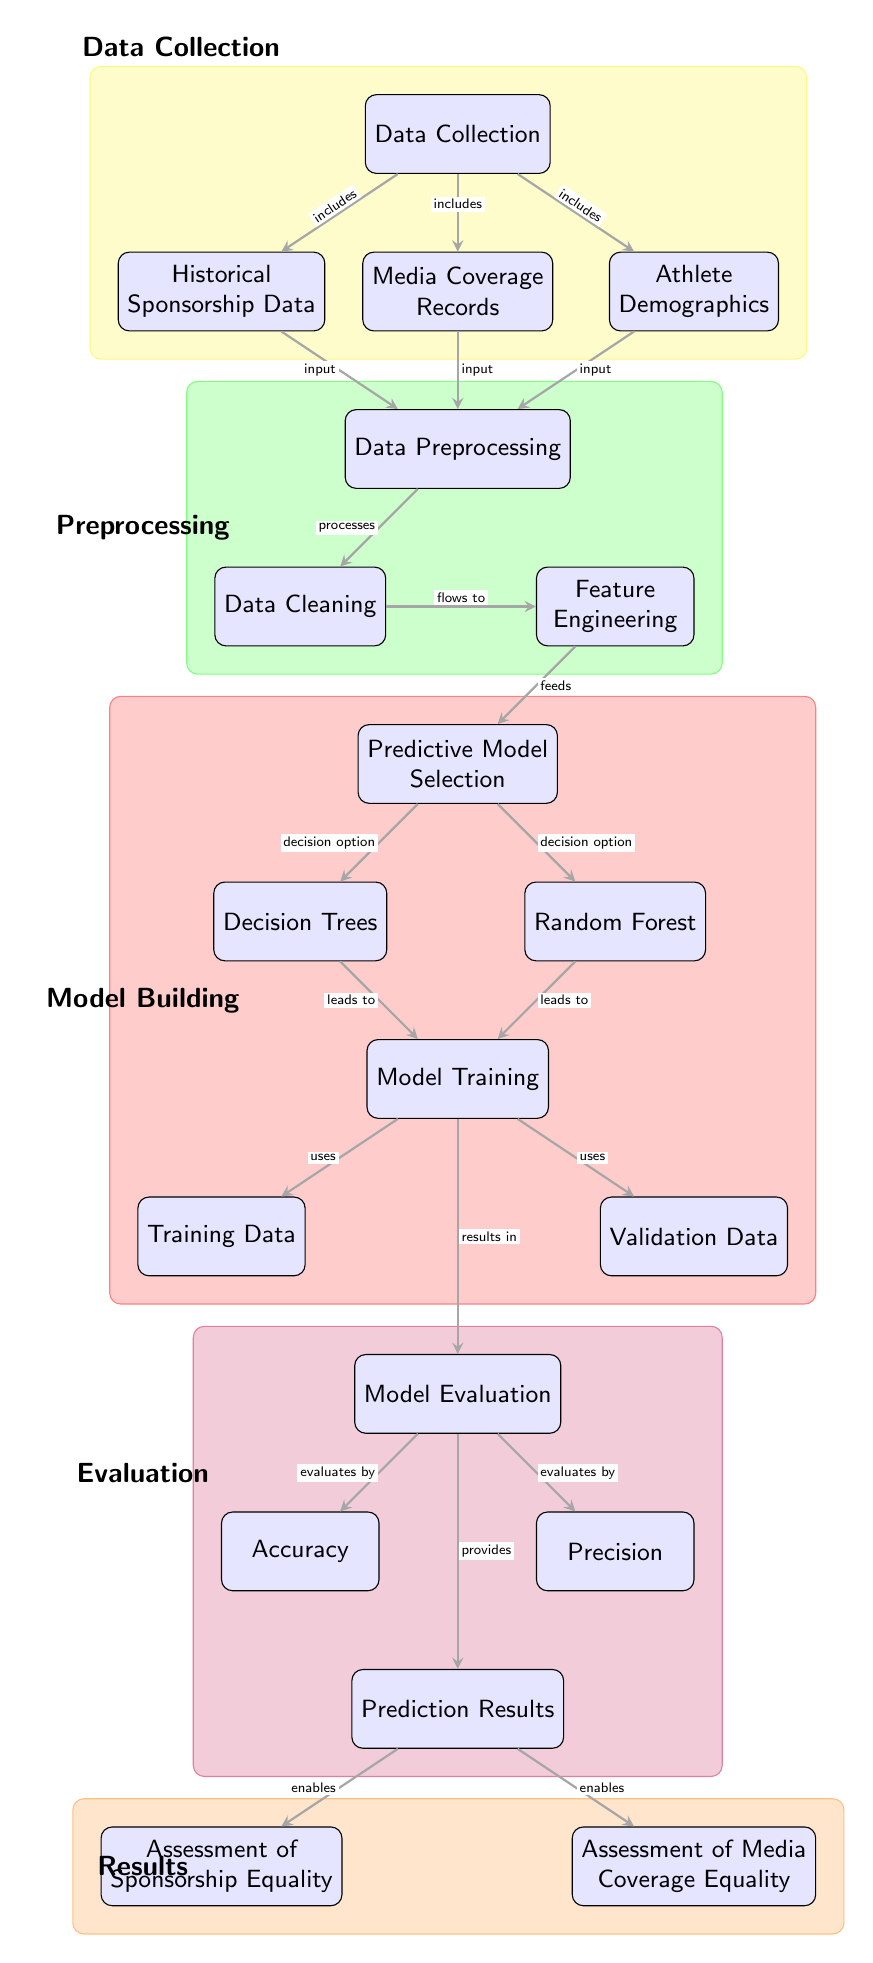What is the first step in the diagram? The first step in the diagram is "Data Collection," located at the top of the flow, indicating that the process begins with gathering relevant data.
Answer: Data Collection How many types of predictive models are mentioned in the diagram? The diagram mentions two types of predictive models: "Decision Trees" and "Random Forest," which can be found at the same level under "Predictive Model Selection."
Answer: Two What are the three main inputs for "Data Preprocessing"? The three main inputs listed for "Data Preprocessing" are "Historical Sponsorship Data," "Media Coverage Records," and "Athlete Demographics," which all connect to this node.
Answer: Historical Sponsorship Data, Media Coverage Records, Athlete Demographics What does "Model Evaluation" result in? "Model Evaluation" leads to three evaluations: "Accuracy," "Precision," and "Prediction Results," indicating the metrics and outcomes assessed after training the models.
Answer: Accuracy, Precision, Prediction Results How does "Prediction Results" affect the assessments of equality? "Prediction Results" enables both "Assessment of Sponsorship Equality" and "Assessment of Media Coverage Equality," showing that the outcomes from predictions inform these assessments.
Answer: Enables Which part of the diagram focuses on data preparation? The part of the diagram that focuses on data preparation is "Data Preprocessing," which includes "Data Cleaning" and "Feature Engineering," indicating its role in preparing the collected data for modeling.
Answer: Data Preprocessing What are the two types of data used in model training? The two types of data used in "Model Training" are "Training Data" and "Validation Data," showing that both datasets are crucial for training and validating the models.
Answer: Training Data, Validation Data Which phase in the diagram contains the node "Assessment of Media Coverage Equality"? The "Results" phase of the diagram contains the node "Assessment of Media Coverage Equality," which is located at the bottom section of the flow.
Answer: Results What kind of analysis does the diagram primarily focus on? The diagram primarily focuses on "Predictive Analytics for Sponsorship and Media Coverage Equality," indicating its objective to analyze sponsorship and media coverage related to athletes' backgrounds.
Answer: Predictive Analytics for Sponsorship and Media Coverage Equality 